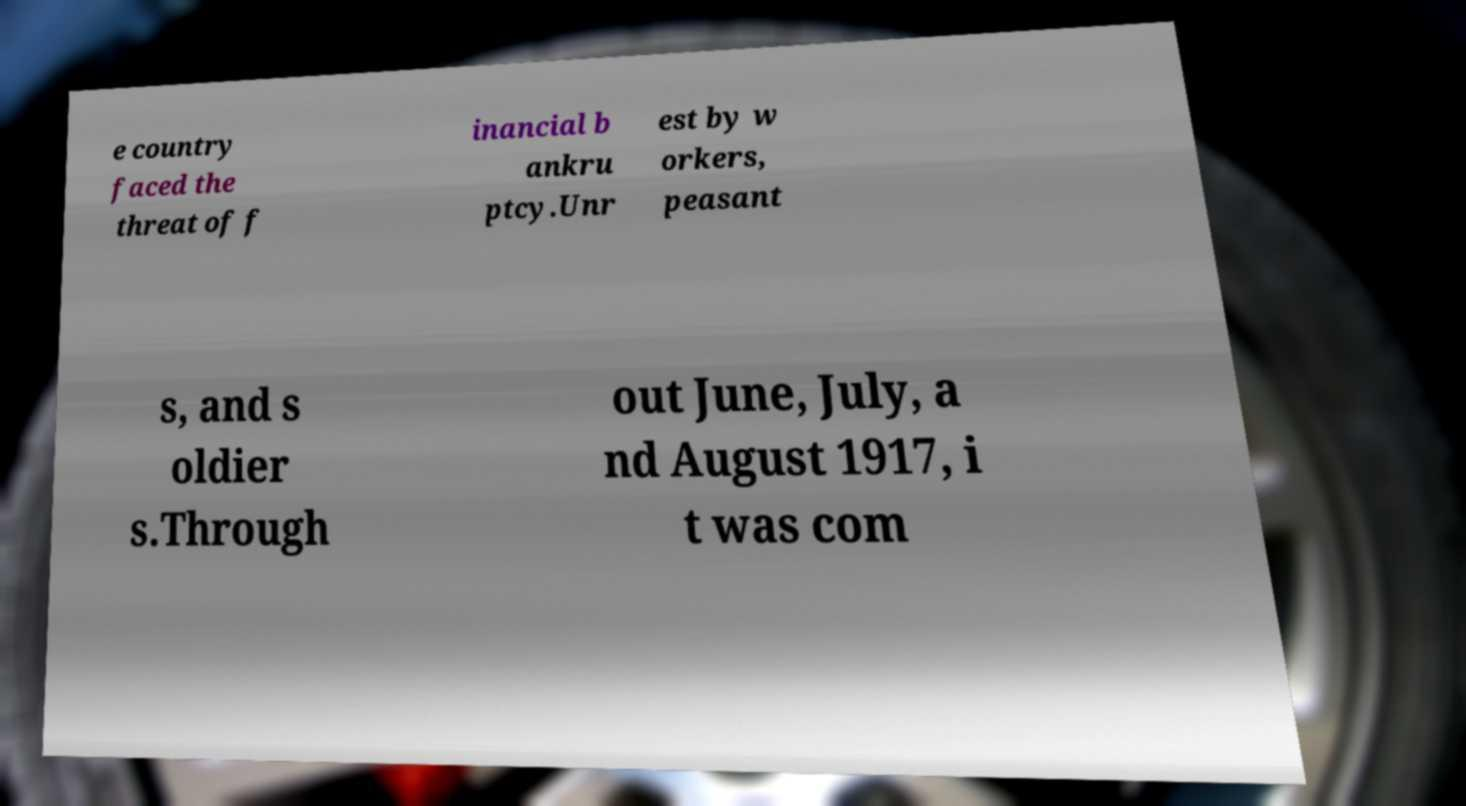Could you assist in decoding the text presented in this image and type it out clearly? e country faced the threat of f inancial b ankru ptcy.Unr est by w orkers, peasant s, and s oldier s.Through out June, July, a nd August 1917, i t was com 